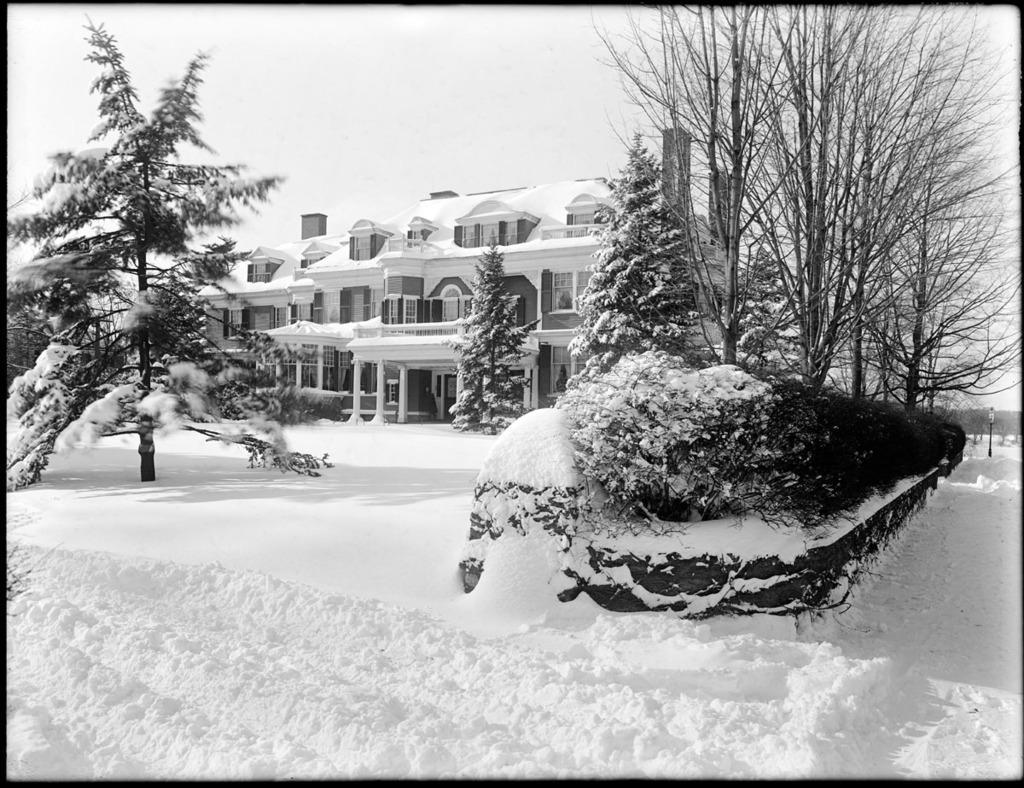Can you describe this image briefly? In this image there are trees, bushes, buildings and a light pole. At the bottom of the image there is snow on the surface. At the top of the image there is sky. 